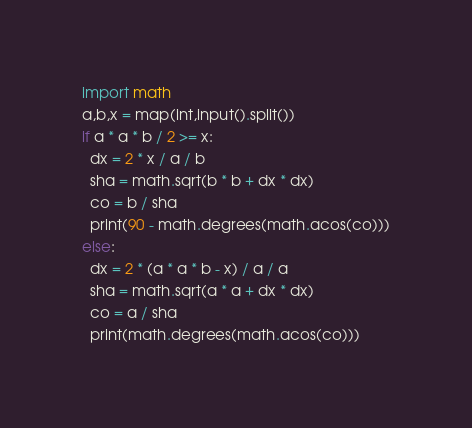<code> <loc_0><loc_0><loc_500><loc_500><_Python_>import math
a,b,x = map(int,input().split())
if a * a * b / 2 >= x:
  dx = 2 * x / a / b
  sha = math.sqrt(b * b + dx * dx)
  co = b / sha
  print(90 - math.degrees(math.acos(co)))
else:
  dx = 2 * (a * a * b - x) / a / a
  sha = math.sqrt(a * a + dx * dx)
  co = a / sha
  print(math.degrees(math.acos(co)))</code> 